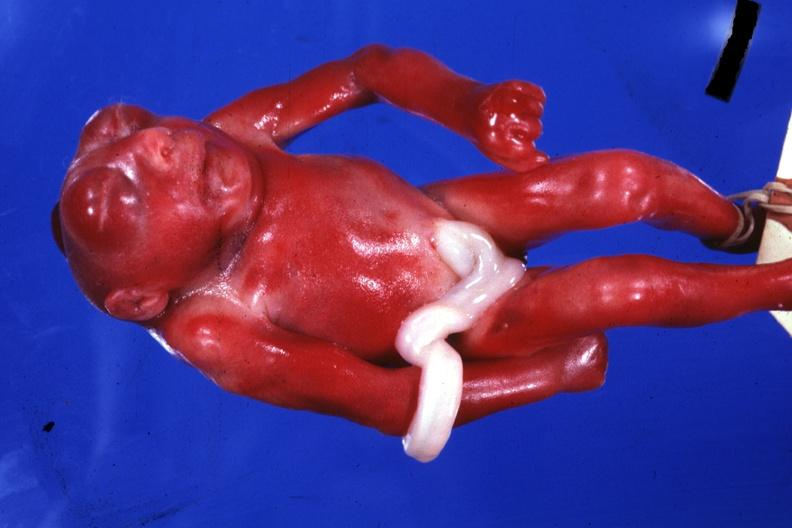does this image show whole body small fetus typical?
Answer the question using a single word or phrase. Yes 